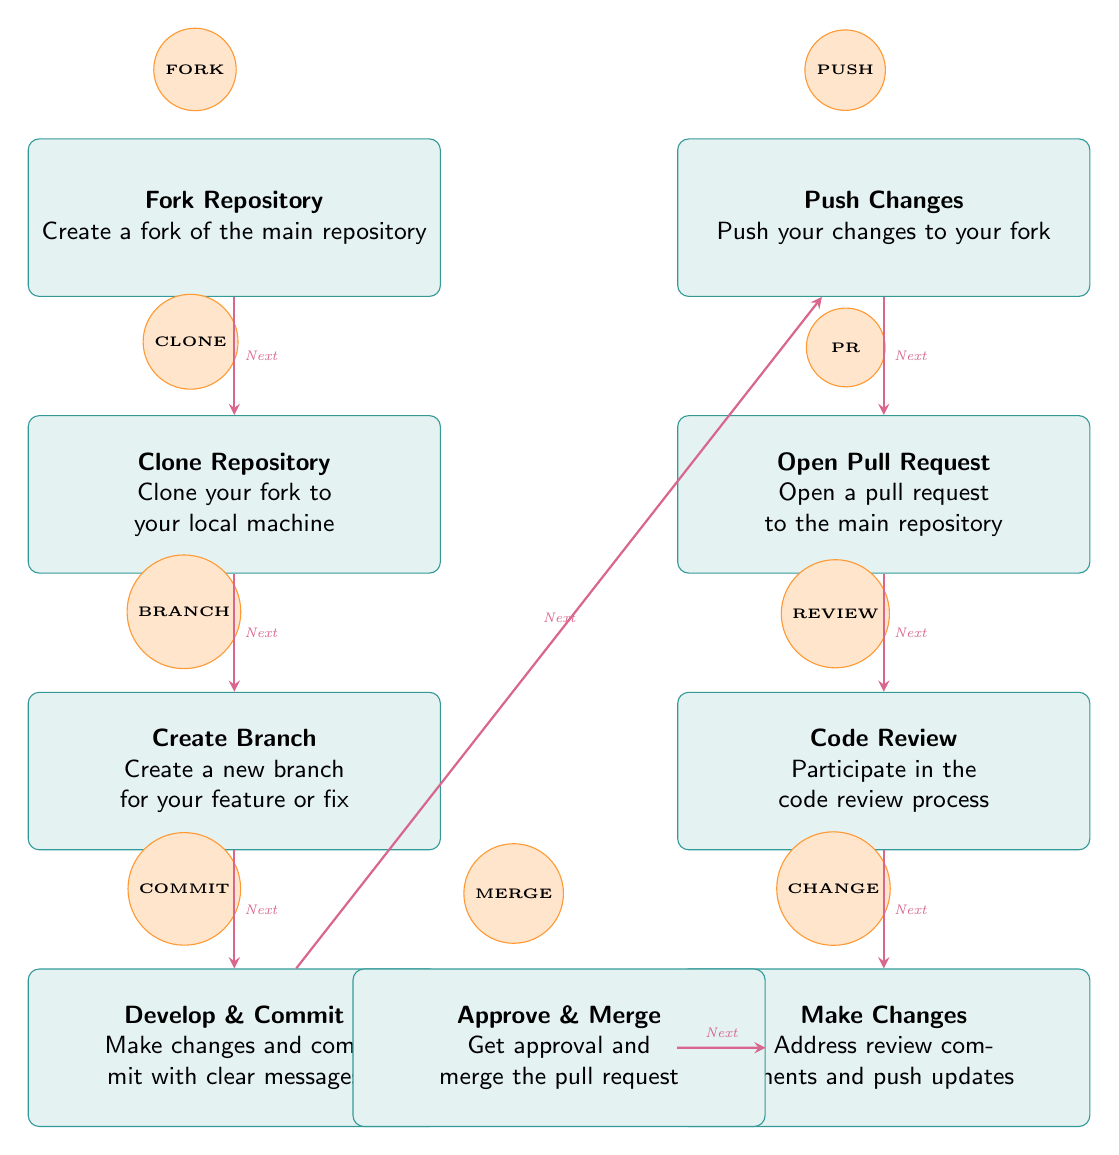What is the first step in the workflow? The diagram starts with the first node labeled "Fork Repository," which indicates that creating a fork of the main repository is the initial action.
Answer: Fork Repository How many main processes are depicted in the diagram? By counting the number of boxes, which represent the main steps in the workflow, we find eight boxes indicating eight processes.
Answer: Eight What step comes after "Open Pull Request"? Following "Open Pull Request," the next step shown in the diagram is "Code Review," which is positioned directly beneath this step.
Answer: Code Review Which step involves pushing changes to your fork? The diagram shows "Push Changes" as the step where you push your changes to your fork, located to the right of "Clone Repository."
Answer: Push Changes What must happen before merging a pull request? The step "Code Review" must occur before merging, as indicated by the arrows pointing from "Open Pull Request" to "Code Review" and then to "Make Changes" before reaching the "Approve & Merge."
Answer: Code Review How are the steps connected in the diagram? Each step is connected by arrows that indicate the flow of the process, where the arrows all point downward, showing the sequence from one action to the next in the workflow.
Answer: By arrows What is the purpose of the "Make Changes" step? The "Make Changes" step is where contributors address review comments and update their code before the pull request can be merged, emphasizing the importance of feedback in the process.
Answer: Address review comments What does the icon next to "Fork Repository" represent? The icon next to "Fork Repository" is a circular visual element labeled "FORK," illustrating the action of creating a fork in the visual representation of this step.
Answer: FORK 